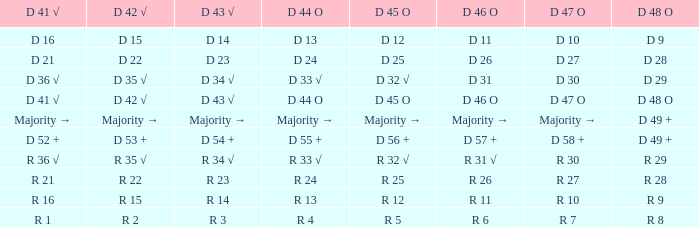Name the D 45 O with D 44 O majority → Majority →. 